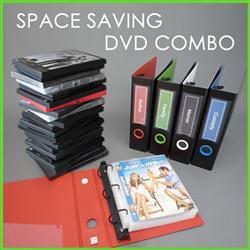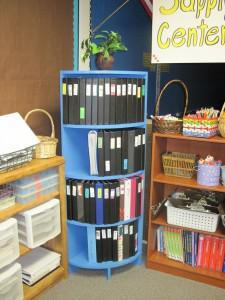The first image is the image on the left, the second image is the image on the right. Examine the images to the left and right. Is the description "A bookshelf with 5 shelves is standing by a wall." accurate? Answer yes or no. No. The first image is the image on the left, the second image is the image on the right. Analyze the images presented: Is the assertion "In one image, a wooden book shelf with six shelves is standing against a wall." valid? Answer yes or no. No. 